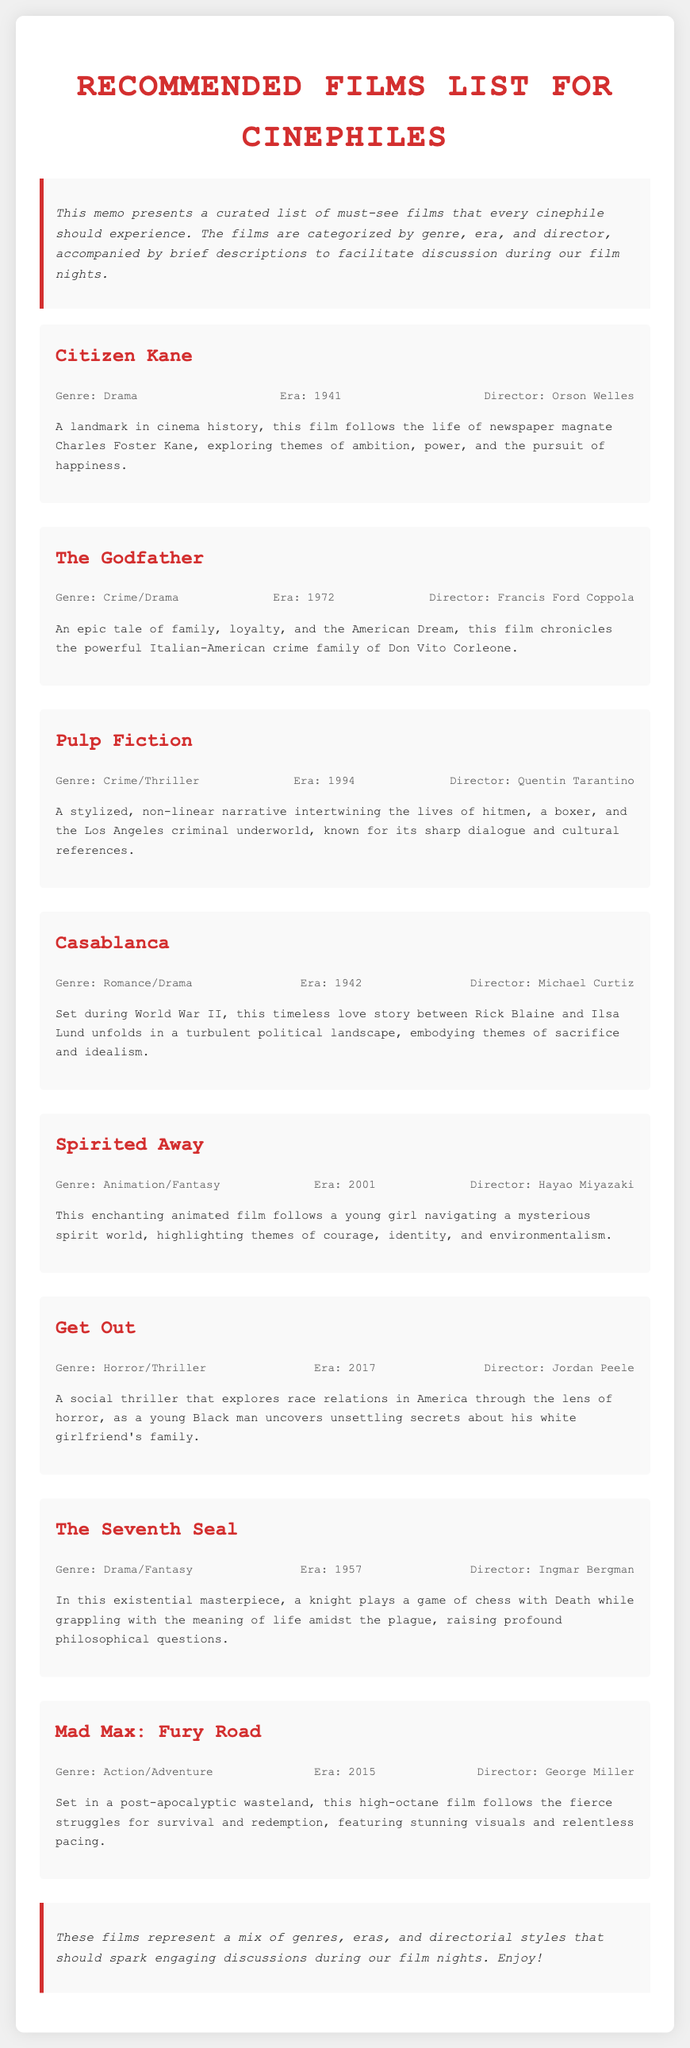What is the title of the first film listed? The title of the first film in the document is provided in the film section.
Answer: Citizen Kane Who directed "The Godfather"? The document specifies the director of "The Godfather" under the film information section.
Answer: Francis Ford Coppola In what year was "Spirited Away" released? The release year for "Spirited Away" is mentioned in the era section of the film description.
Answer: 2001 What genre does "Get Out" belong to? The genre of "Get Out" can be found in the corresponding film information line.
Answer: Horror/Thriller How many films are categorized in the list? The total number of films can be counted from the individual film sections provided.
Answer: Eight Which film explores themes of ambition and power? Themes associated with "Citizen Kane" are mentioned in its brief description.
Answer: Citizen Kane What is the common theme explored in "The Seventh Seal"? The document indicates that "The Seventh Seal" raises profound philosophical questions, which relate to life and death.
Answer: Life and death Who is the director of "Mad Max: Fury Road"? The film information section lists the director's name for "Mad Max: Fury Road".
Answer: George Miller 